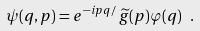<formula> <loc_0><loc_0><loc_500><loc_500>\psi ( q , p ) = e ^ { - i p q / } \, \widetilde { g } ( p ) \varphi ( q ) \ .</formula> 